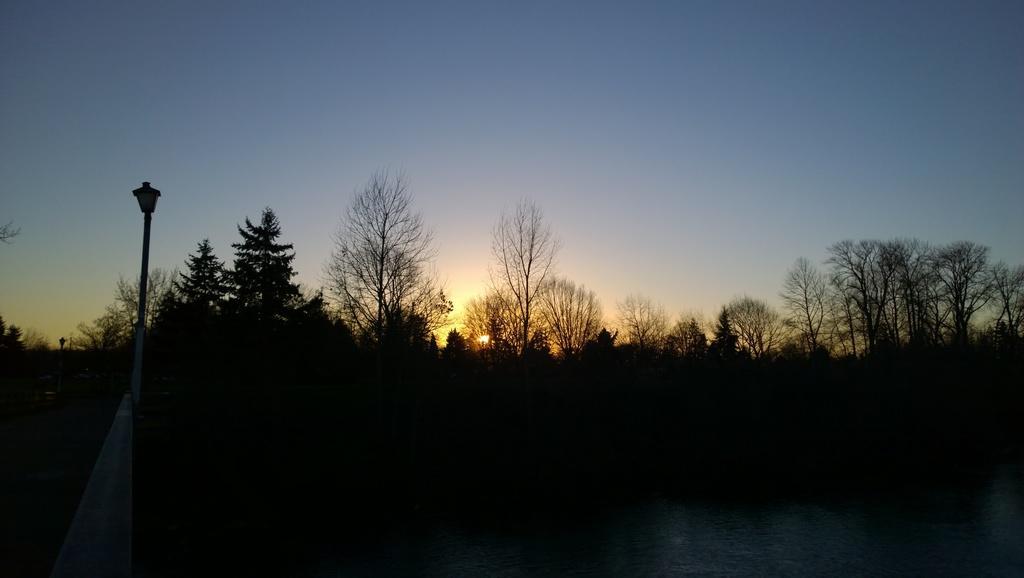Could you give a brief overview of what you see in this image? In front of the image there is water. There are trees. On the left side of the image there are light poles. In the background of the image there is sun in the sky. 